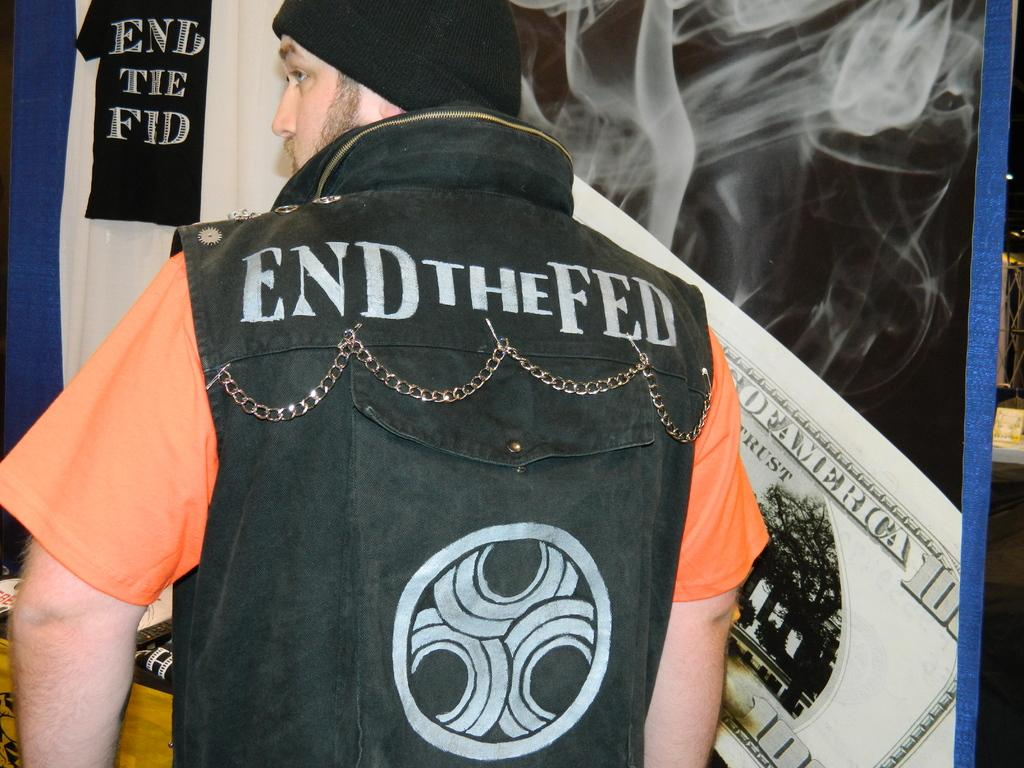<image>
Present a compact description of the photo's key features. A man in a vest that says End the Fed on the back 